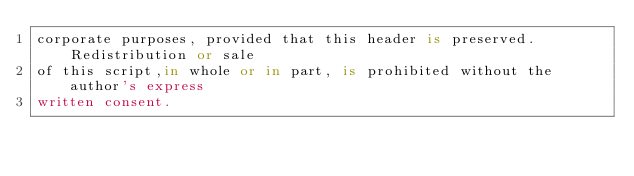<code> <loc_0><loc_0><loc_500><loc_500><_SQL_>corporate purposes, provided that this header is preserved. Redistribution or sale 
of this script,in whole or in part, is prohibited without the author's express 
written consent. 
</code> 